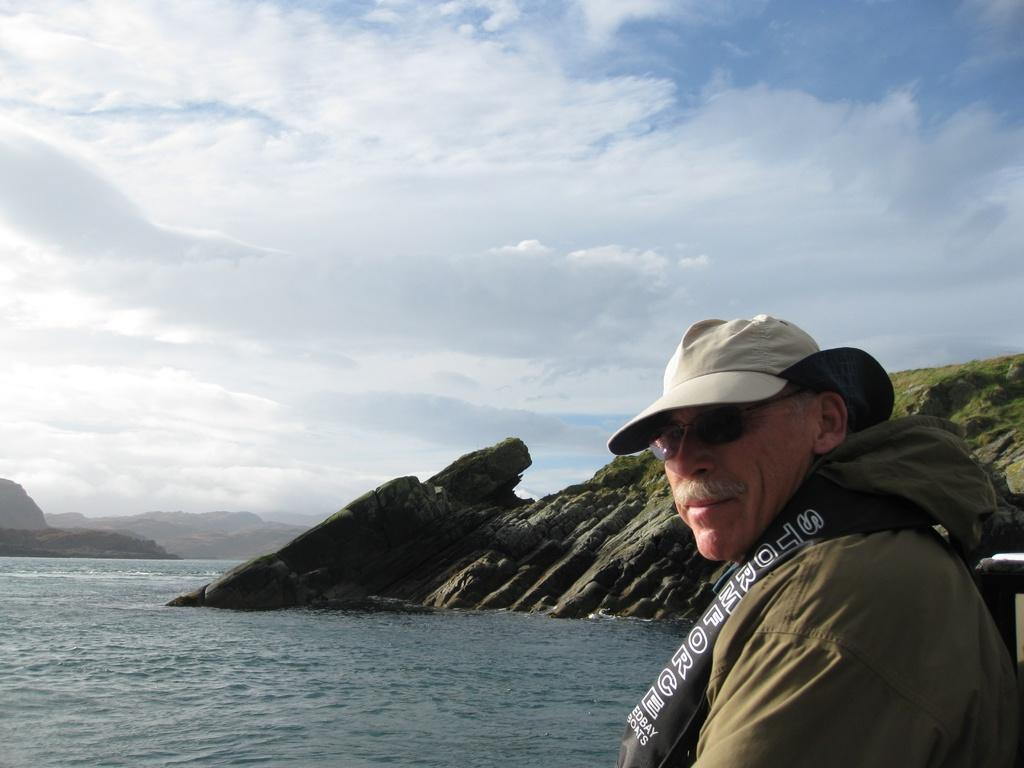What type of landscape can be seen in the image? There are hills in the image. What natural element is visible in the image? There is water visible in the image. What is the person in the image wearing? The person in the image is wearing goggles and a hat. What is visible at the top of the image? The sky is visible at the top of the image. What can be seen in the sky? Clouds are present in the sky. What type of bat is flying near the person in the image? There is no bat present in the image; it features hills, water, a person wearing goggles and a hat, and clouds in the sky. 